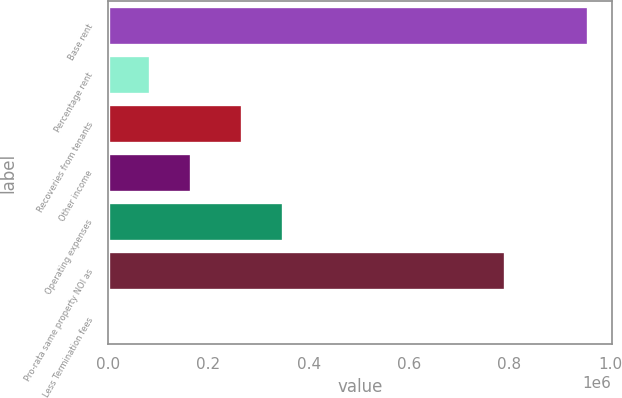Convert chart to OTSL. <chart><loc_0><loc_0><loc_500><loc_500><bar_chart><fcel>Base rent<fcel>Percentage rent<fcel>Recoveries from tenants<fcel>Other income<fcel>Operating expenses<fcel>Pro-rata same property NOI as<fcel>Less Termination fees<nl><fcel>955730<fcel>83523.6<fcel>266274<fcel>165825<fcel>348576<fcel>791127<fcel>1222<nl></chart> 